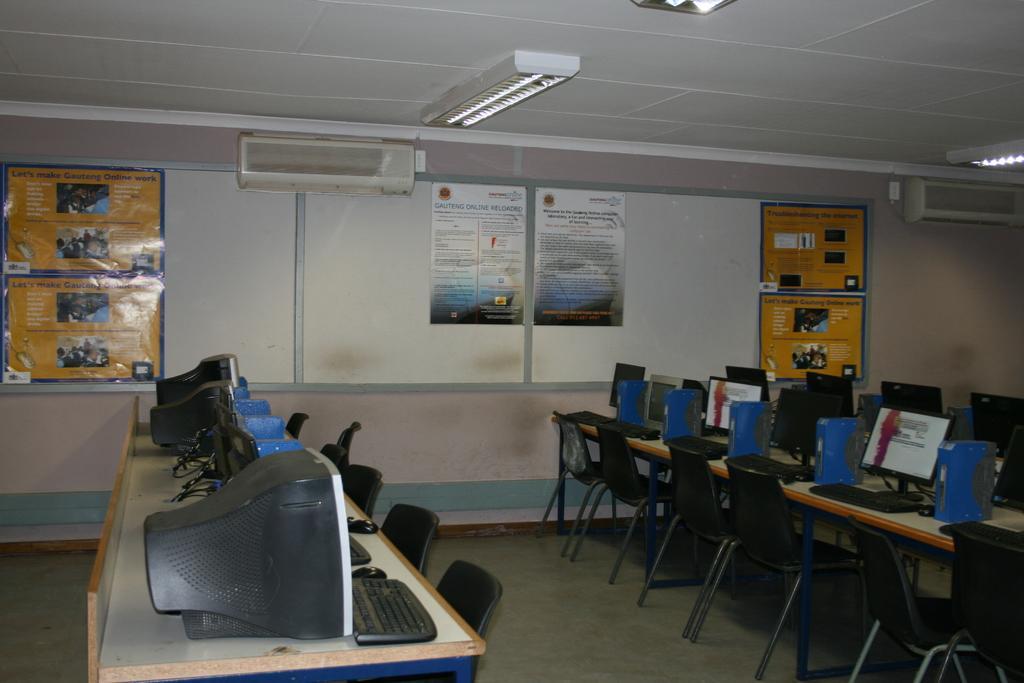Please provide a concise description of this image. As we can see in the image there is a wall, banners, lights, air conditioners, tables, screen and chairs. 